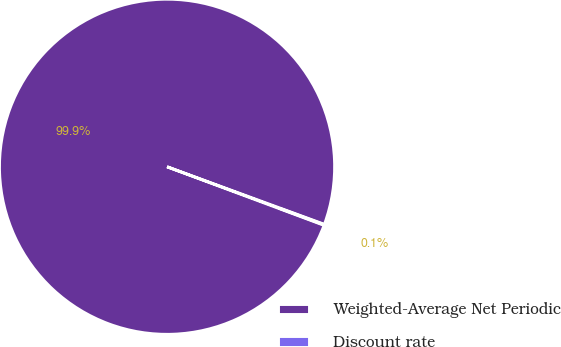Convert chart to OTSL. <chart><loc_0><loc_0><loc_500><loc_500><pie_chart><fcel>Weighted-Average Net Periodic<fcel>Discount rate<nl><fcel>99.9%<fcel>0.1%<nl></chart> 